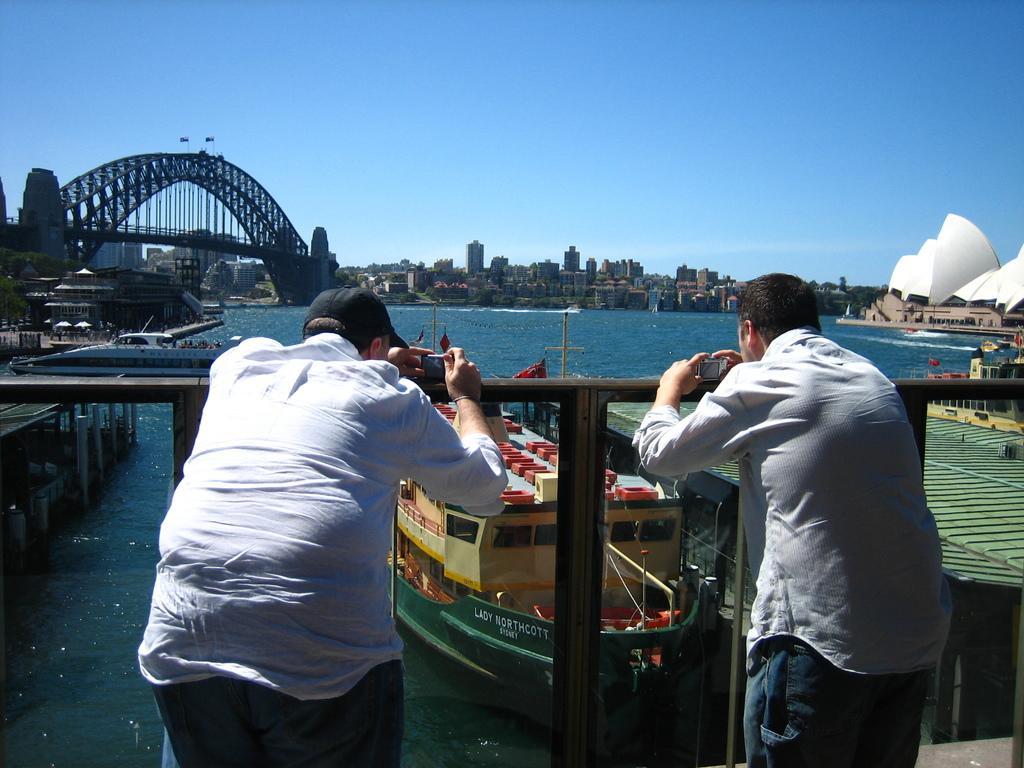In one or two sentences, can you explain what this image depicts? In this image we can see two persons wearing white color shirts leaning to the fencing holding camera in their hands and at the background of the image there are some boats, bridge, buildings and clear sky. 